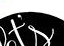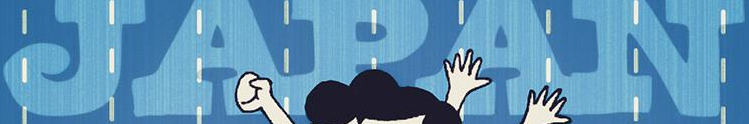What text is displayed in these images sequentially, separated by a semicolon? t's; JAPAN 